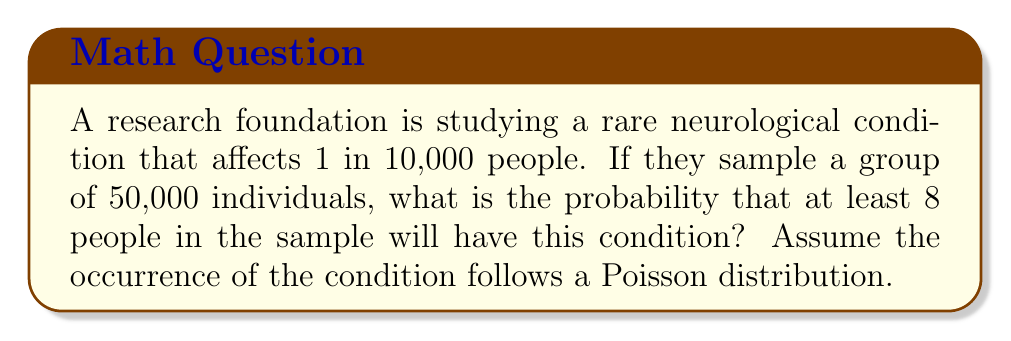What is the answer to this math problem? Let's approach this step-by-step:

1) First, we need to calculate the expected number of people with the condition in our sample:
   $\lambda = 50,000 \cdot \frac{1}{10,000} = 5$

2) We're using a Poisson distribution with $\lambda = 5$. We want the probability of 8 or more occurrences.

3) It's often easier to calculate the probability of 7 or fewer occurrences and then subtract from 1:

   $P(X \geq 8) = 1 - P(X \leq 7)$

4) The cumulative probability function for Poisson distribution is:

   $P(X \leq k) = e^{-\lambda} \sum_{i=0}^k \frac{\lambda^i}{i!}$

5) So, we need to calculate:

   $1 - e^{-5} \sum_{i=0}^7 \frac{5^i}{i!}$

6) Expanding this:

   $1 - e^{-5} (1 + 5 + \frac{5^2}{2!} + \frac{5^3}{3!} + \frac{5^4}{4!} + \frac{5^5}{5!} + \frac{5^6}{6!} + \frac{5^7}{7!})$

7) Calculating this (using a calculator or computer for precision):

   $1 - 0.9586$ = $0.0414$

Therefore, the probability of at least 8 people having the condition in the sample is approximately 0.0414 or 4.14%.
Answer: 0.0414 